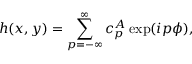Convert formula to latex. <formula><loc_0><loc_0><loc_500><loc_500>h ( x , y ) = \sum _ { p = - \infty } ^ { \infty } c _ { p } ^ { A } \exp ( i p \phi ) ,</formula> 